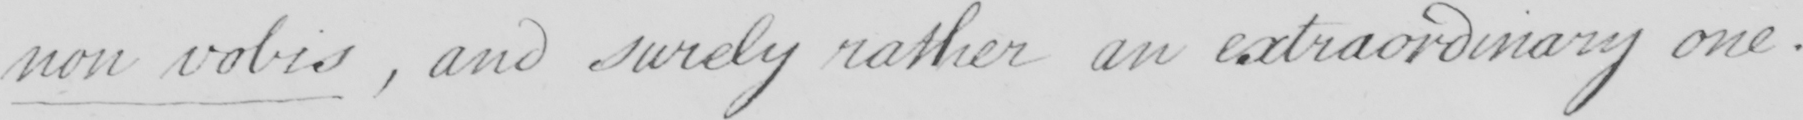Transcribe the text shown in this historical manuscript line. non vobis  , and surely rather an extraordinary one . 